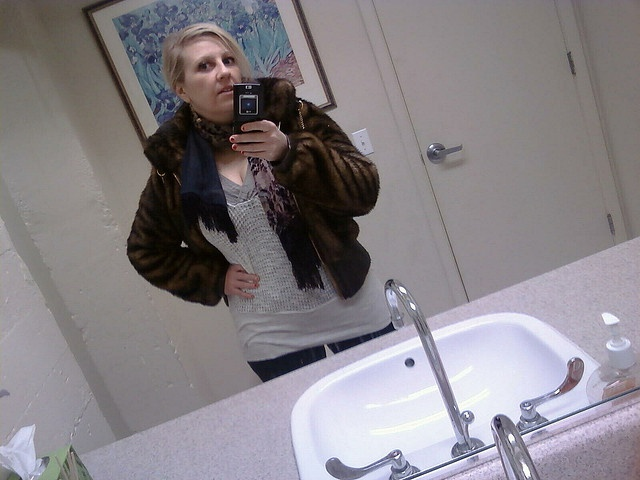Describe the objects in this image and their specific colors. I can see people in gray and black tones, sink in gray, lavender, and darkgray tones, bottle in gray, darkgray, and lavender tones, and cell phone in gray and black tones in this image. 